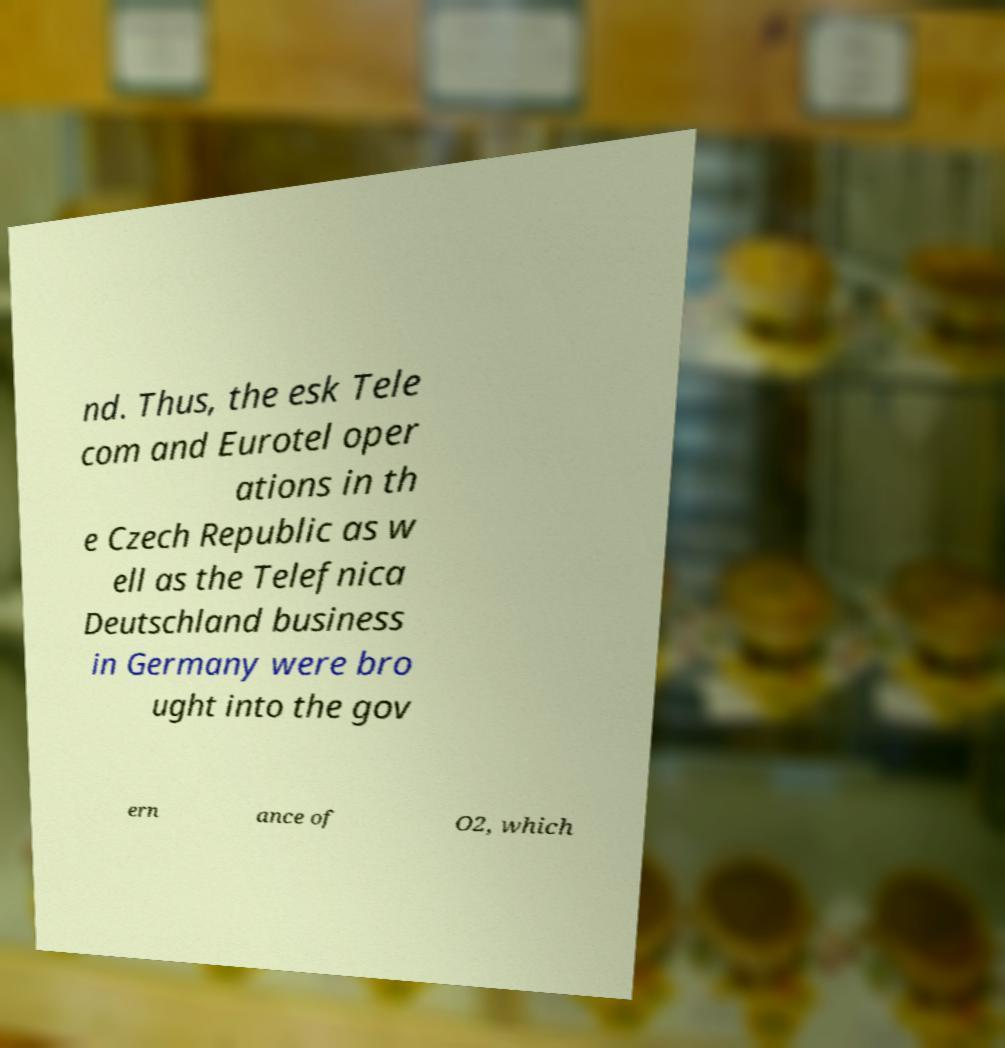Please read and relay the text visible in this image. What does it say? nd. Thus, the esk Tele com and Eurotel oper ations in th e Czech Republic as w ell as the Telefnica Deutschland business in Germany were bro ught into the gov ern ance of O2, which 